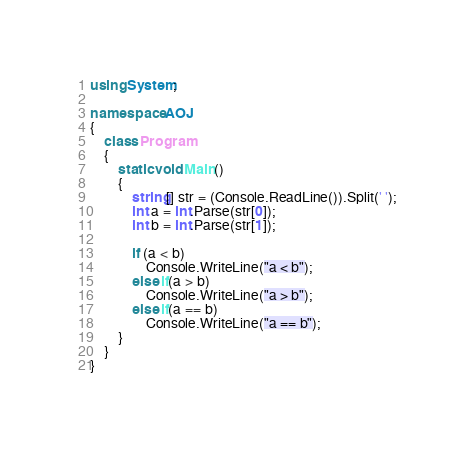Convert code to text. <code><loc_0><loc_0><loc_500><loc_500><_C#_>using System;

namespace AOJ
{
    class Program
    {
        static void Main()
        {
            string[] str = (Console.ReadLine()).Split(' ');
            int a = int.Parse(str[0]);
            int b = int.Parse(str[1]);

            if (a < b)
                Console.WriteLine("a < b");
            else if(a > b)
                Console.WriteLine("a > b");
            else if(a == b)
                Console.WriteLine("a == b");
        }
    }
}</code> 